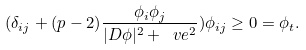Convert formula to latex. <formula><loc_0><loc_0><loc_500><loc_500>( \delta _ { i j } + ( p - 2 ) \frac { \phi _ { i } \phi _ { j } } { | D \phi | ^ { 2 } + \ v e ^ { 2 } } ) \phi _ { i j } \geq 0 = \phi _ { t } .</formula> 